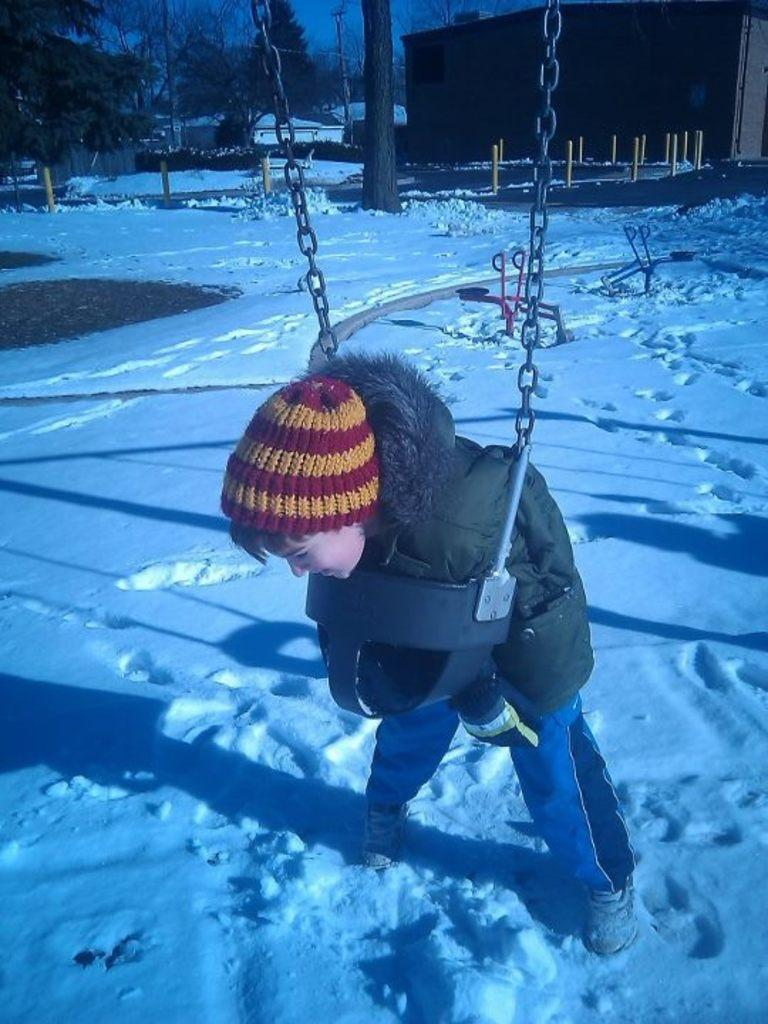Who is the main subject in the image? There is a boy in the center of the image. What is the boy doing in the image? The boy is playing. What type of environment is depicted in the image? There is snow at the bottom of the image, and there are trees and houses in the background. What else can be seen in the image? There are rods visible in the image. What type of feast is being prepared in the image? There is no indication of a feast being prepared in the image; it primarily features a boy playing in the snow. What system is responsible for the snow in the image? The image does not provide information about the system responsible for the snow; it simply shows snow on the ground. 